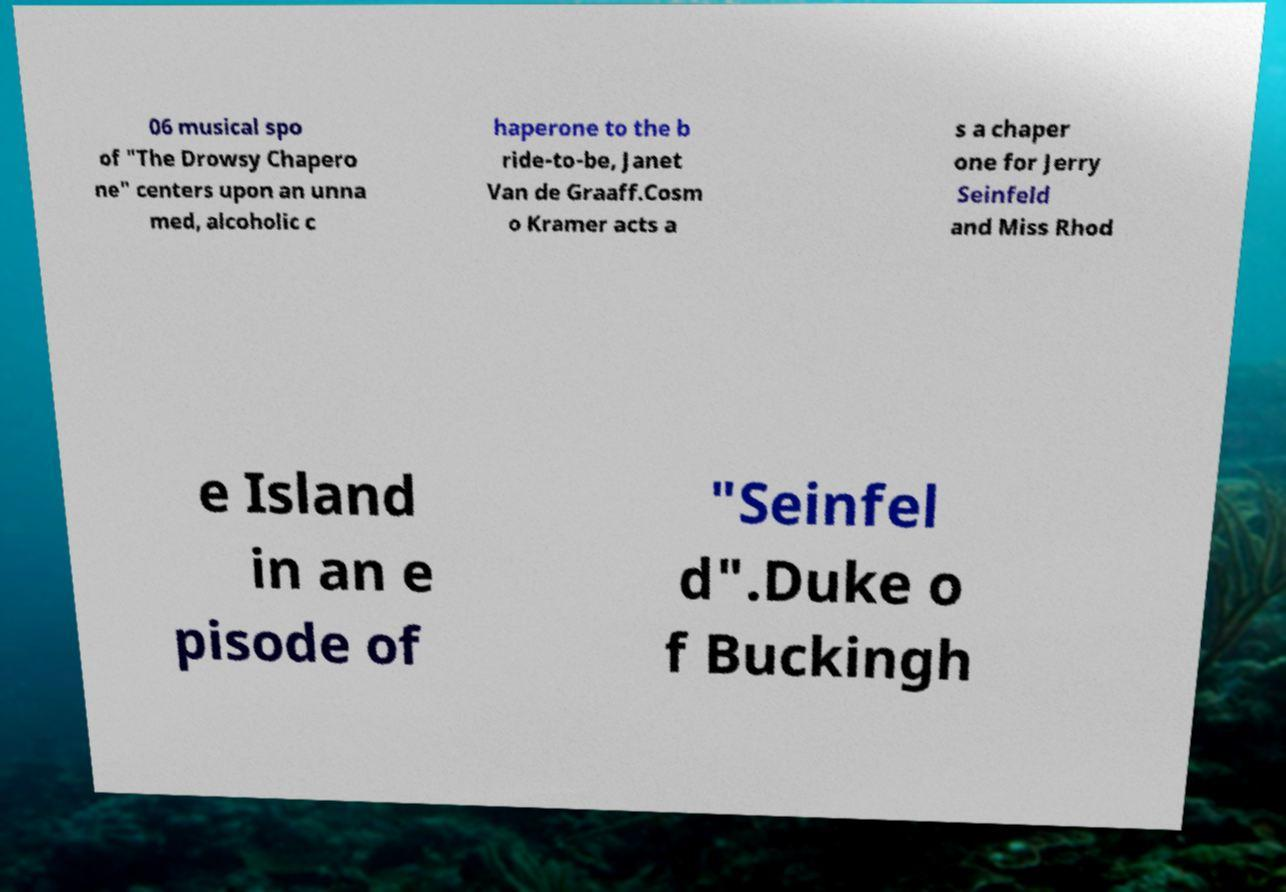For documentation purposes, I need the text within this image transcribed. Could you provide that? 06 musical spo of "The Drowsy Chapero ne" centers upon an unna med, alcoholic c haperone to the b ride-to-be, Janet Van de Graaff.Cosm o Kramer acts a s a chaper one for Jerry Seinfeld and Miss Rhod e Island in an e pisode of "Seinfel d".Duke o f Buckingh 